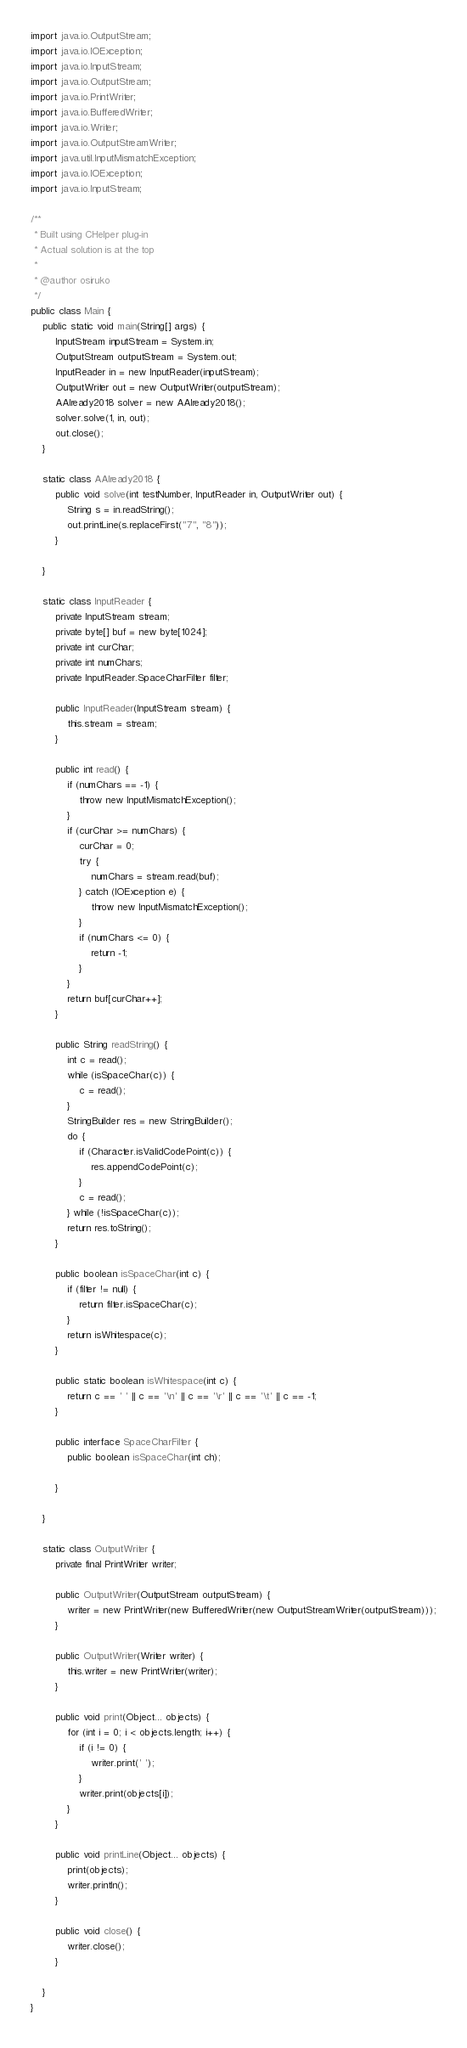Convert code to text. <code><loc_0><loc_0><loc_500><loc_500><_Java_>import java.io.OutputStream;
import java.io.IOException;
import java.io.InputStream;
import java.io.OutputStream;
import java.io.PrintWriter;
import java.io.BufferedWriter;
import java.io.Writer;
import java.io.OutputStreamWriter;
import java.util.InputMismatchException;
import java.io.IOException;
import java.io.InputStream;

/**
 * Built using CHelper plug-in
 * Actual solution is at the top
 *
 * @author osiruko
 */
public class Main {
    public static void main(String[] args) {
        InputStream inputStream = System.in;
        OutputStream outputStream = System.out;
        InputReader in = new InputReader(inputStream);
        OutputWriter out = new OutputWriter(outputStream);
        AAlready2018 solver = new AAlready2018();
        solver.solve(1, in, out);
        out.close();
    }

    static class AAlready2018 {
        public void solve(int testNumber, InputReader in, OutputWriter out) {
            String s = in.readString();
            out.printLine(s.replaceFirst("7", "8"));
        }

    }

    static class InputReader {
        private InputStream stream;
        private byte[] buf = new byte[1024];
        private int curChar;
        private int numChars;
        private InputReader.SpaceCharFilter filter;

        public InputReader(InputStream stream) {
            this.stream = stream;
        }

        public int read() {
            if (numChars == -1) {
                throw new InputMismatchException();
            }
            if (curChar >= numChars) {
                curChar = 0;
                try {
                    numChars = stream.read(buf);
                } catch (IOException e) {
                    throw new InputMismatchException();
                }
                if (numChars <= 0) {
                    return -1;
                }
            }
            return buf[curChar++];
        }

        public String readString() {
            int c = read();
            while (isSpaceChar(c)) {
                c = read();
            }
            StringBuilder res = new StringBuilder();
            do {
                if (Character.isValidCodePoint(c)) {
                    res.appendCodePoint(c);
                }
                c = read();
            } while (!isSpaceChar(c));
            return res.toString();
        }

        public boolean isSpaceChar(int c) {
            if (filter != null) {
                return filter.isSpaceChar(c);
            }
            return isWhitespace(c);
        }

        public static boolean isWhitespace(int c) {
            return c == ' ' || c == '\n' || c == '\r' || c == '\t' || c == -1;
        }

        public interface SpaceCharFilter {
            public boolean isSpaceChar(int ch);

        }

    }

    static class OutputWriter {
        private final PrintWriter writer;

        public OutputWriter(OutputStream outputStream) {
            writer = new PrintWriter(new BufferedWriter(new OutputStreamWriter(outputStream)));
        }

        public OutputWriter(Writer writer) {
            this.writer = new PrintWriter(writer);
        }

        public void print(Object... objects) {
            for (int i = 0; i < objects.length; i++) {
                if (i != 0) {
                    writer.print(' ');
                }
                writer.print(objects[i]);
            }
        }

        public void printLine(Object... objects) {
            print(objects);
            writer.println();
        }

        public void close() {
            writer.close();
        }

    }
}

</code> 